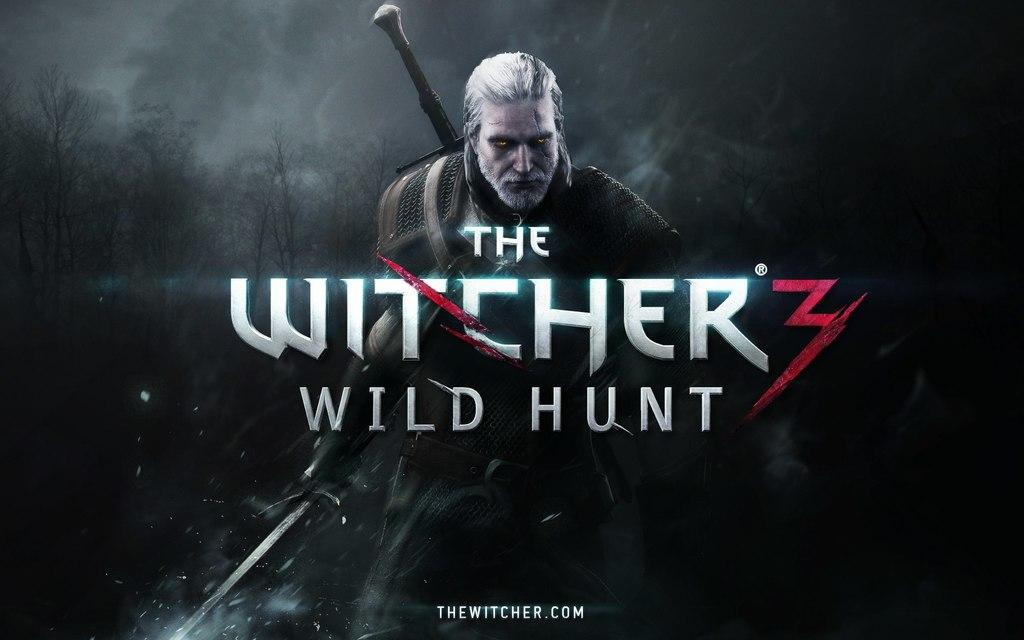<image>
Offer a succinct explanation of the picture presented. A poster for The Witcher Wile Hunt 3 and the url. 